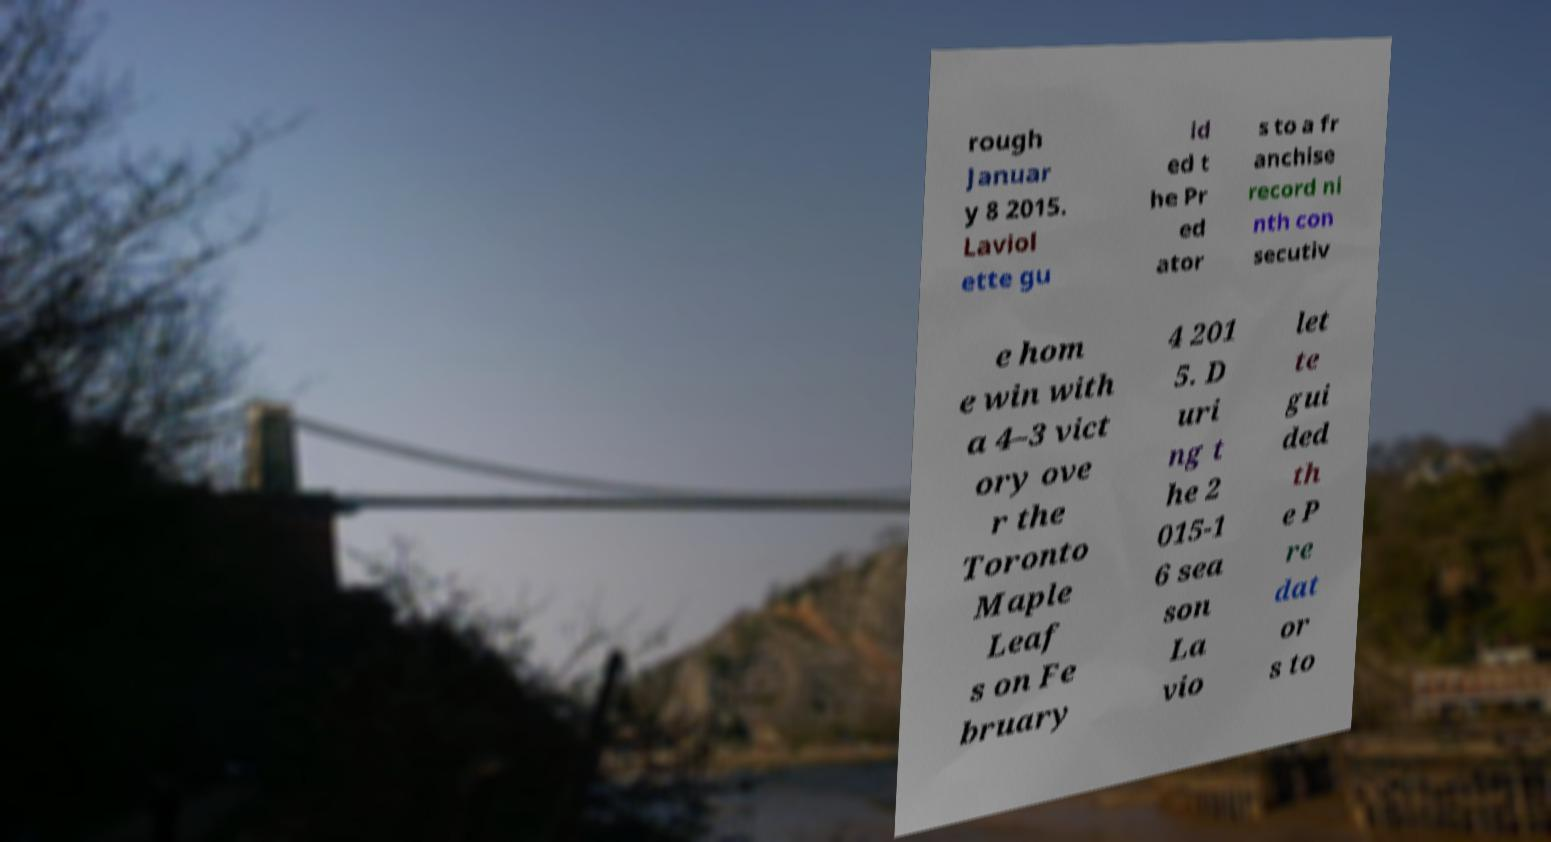There's text embedded in this image that I need extracted. Can you transcribe it verbatim? rough Januar y 8 2015. Laviol ette gu id ed t he Pr ed ator s to a fr anchise record ni nth con secutiv e hom e win with a 4–3 vict ory ove r the Toronto Maple Leaf s on Fe bruary 4 201 5. D uri ng t he 2 015-1 6 sea son La vio let te gui ded th e P re dat or s to 